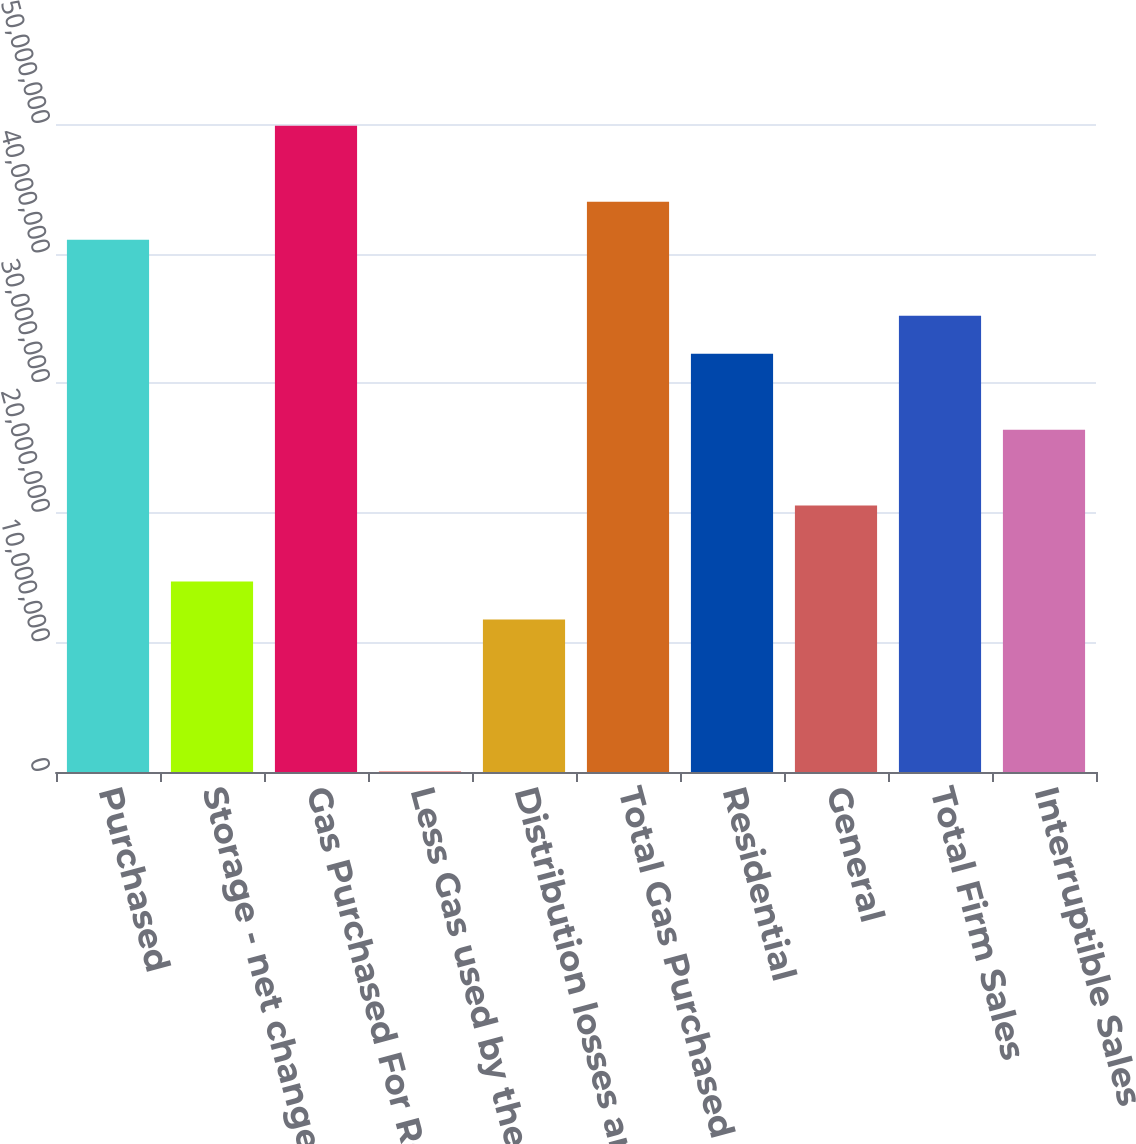<chart> <loc_0><loc_0><loc_500><loc_500><bar_chart><fcel>Purchased<fcel>Storage - net change<fcel>Gas Purchased For Resale<fcel>Less Gas used by the company<fcel>Distribution losses and other<fcel>Total Gas Purchased For O&R<fcel>Residential<fcel>General<fcel>Total Firm Sales<fcel>Interruptible Sales<nl><fcel>4.10671e+07<fcel>1.46965e+07<fcel>4.98573e+07<fcel>46232<fcel>1.17665e+07<fcel>4.39972e+07<fcel>3.22769e+07<fcel>2.05567e+07<fcel>3.5207e+07<fcel>2.64168e+07<nl></chart> 